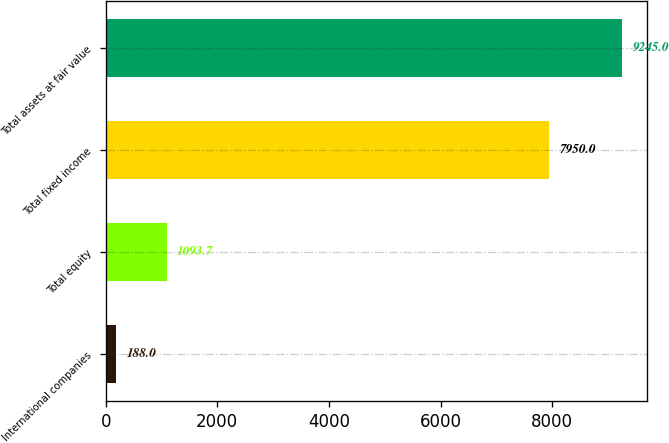Convert chart to OTSL. <chart><loc_0><loc_0><loc_500><loc_500><bar_chart><fcel>International companies<fcel>Total equity<fcel>Total fixed income<fcel>Total assets at fair value<nl><fcel>188<fcel>1093.7<fcel>7950<fcel>9245<nl></chart> 